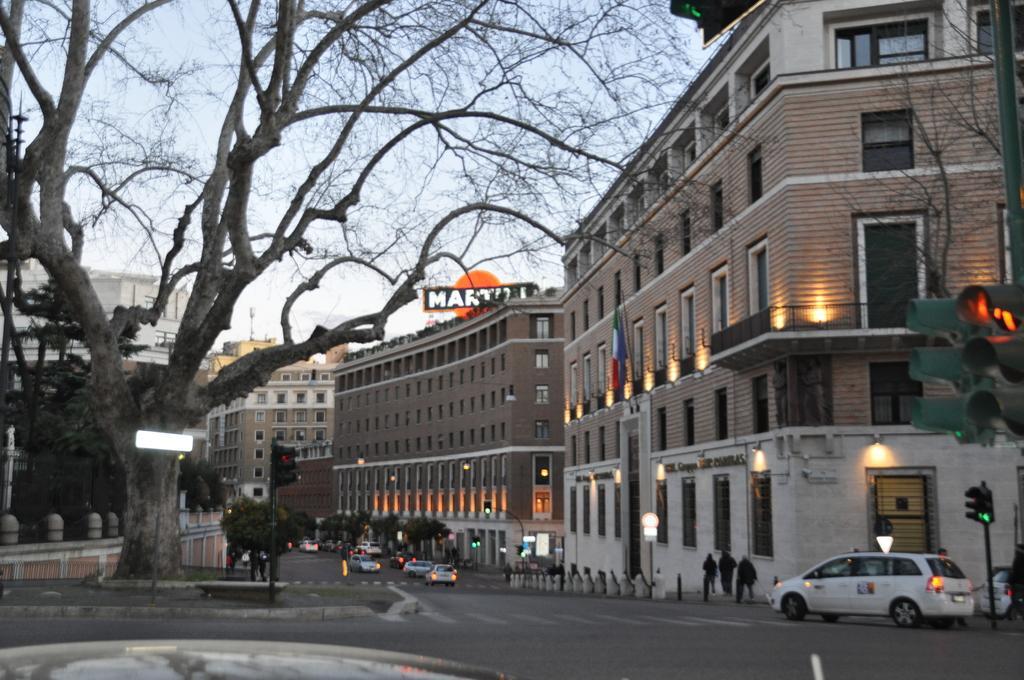Can you describe this image briefly? In this image we can see vehicles on the road. On the sides of the road there are trees. Also there are buildings with windows. And there are lights. And we can see traffic signals with poles. In the background there is sky. On the building there is a name. 